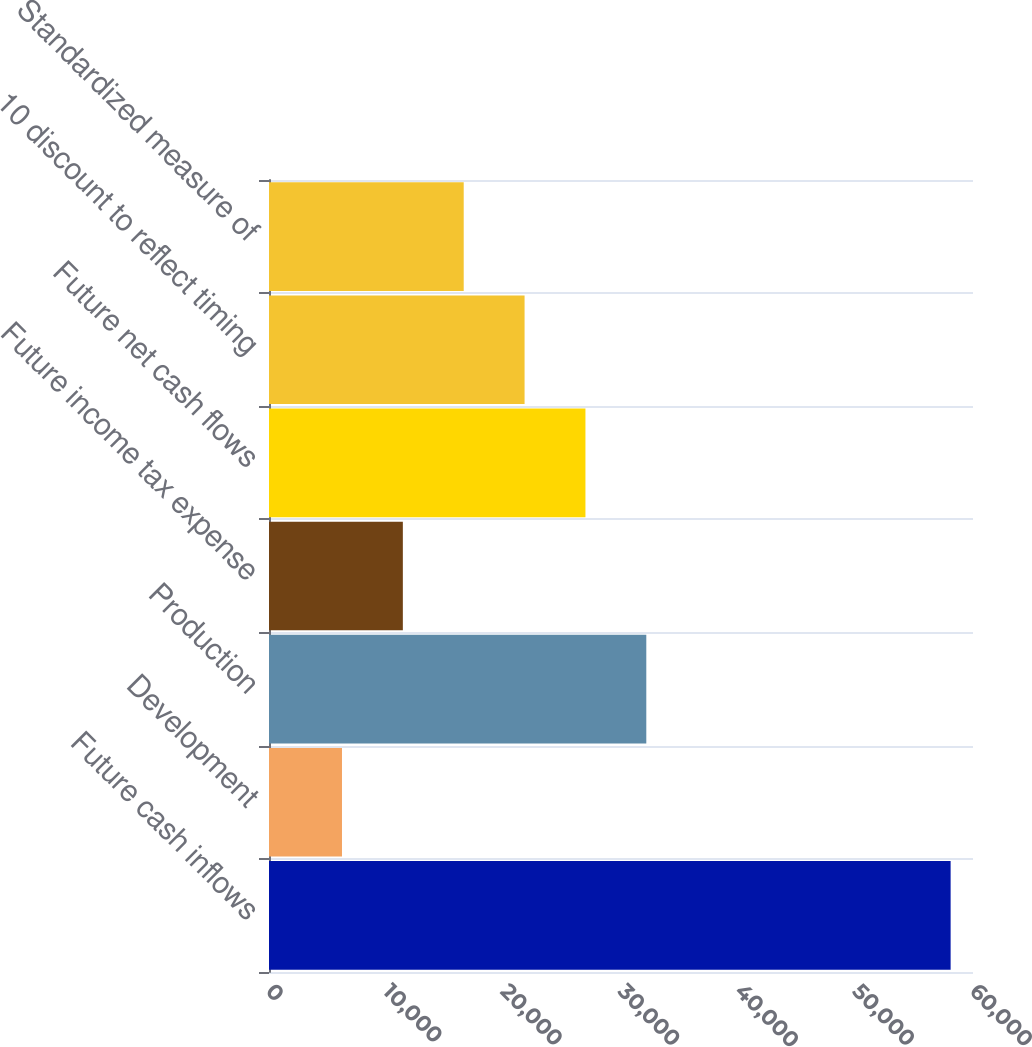Convert chart to OTSL. <chart><loc_0><loc_0><loc_500><loc_500><bar_chart><fcel>Future cash inflows<fcel>Development<fcel>Production<fcel>Future income tax expense<fcel>Future net cash flows<fcel>10 discount to reflect timing<fcel>Standardized measure of<nl><fcel>58093<fcel>6220<fcel>32156.5<fcel>11407.3<fcel>26969.2<fcel>21781.9<fcel>16594.6<nl></chart> 